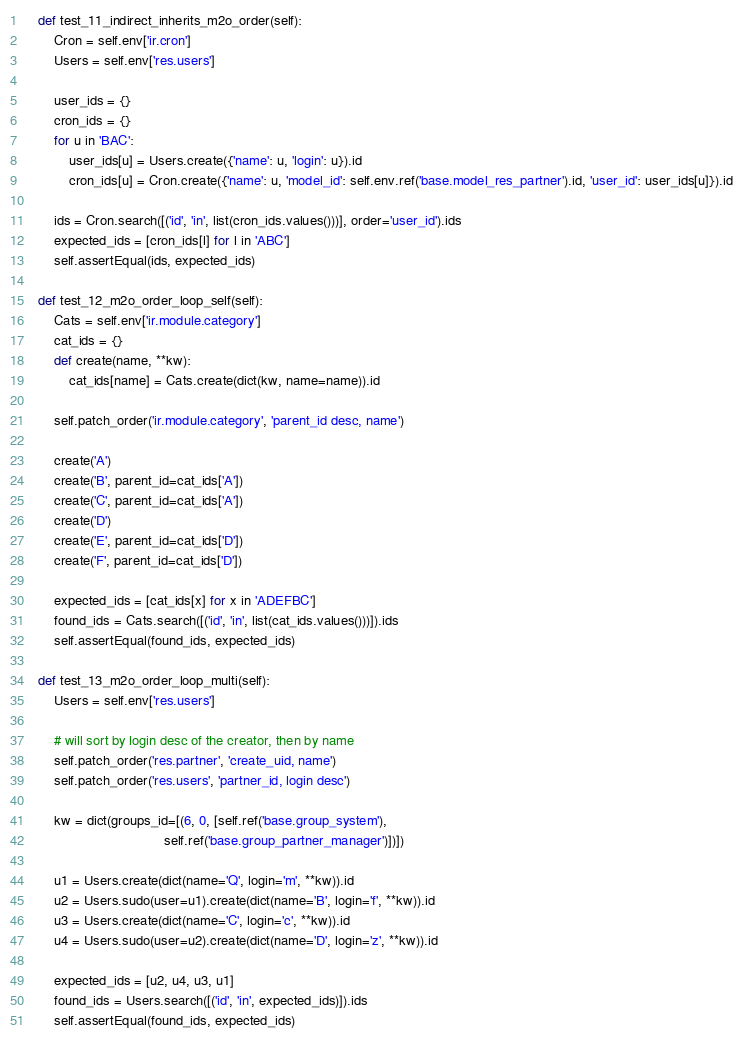<code> <loc_0><loc_0><loc_500><loc_500><_Python_>    def test_11_indirect_inherits_m2o_order(self):
        Cron = self.env['ir.cron']
        Users = self.env['res.users']

        user_ids = {}
        cron_ids = {}
        for u in 'BAC':
            user_ids[u] = Users.create({'name': u, 'login': u}).id
            cron_ids[u] = Cron.create({'name': u, 'model_id': self.env.ref('base.model_res_partner').id, 'user_id': user_ids[u]}).id

        ids = Cron.search([('id', 'in', list(cron_ids.values()))], order='user_id').ids
        expected_ids = [cron_ids[l] for l in 'ABC']
        self.assertEqual(ids, expected_ids)

    def test_12_m2o_order_loop_self(self):
        Cats = self.env['ir.module.category']
        cat_ids = {}
        def create(name, **kw):
            cat_ids[name] = Cats.create(dict(kw, name=name)).id

        self.patch_order('ir.module.category', 'parent_id desc, name')

        create('A')
        create('B', parent_id=cat_ids['A'])
        create('C', parent_id=cat_ids['A'])
        create('D')
        create('E', parent_id=cat_ids['D'])
        create('F', parent_id=cat_ids['D'])

        expected_ids = [cat_ids[x] for x in 'ADEFBC']
        found_ids = Cats.search([('id', 'in', list(cat_ids.values()))]).ids
        self.assertEqual(found_ids, expected_ids)

    def test_13_m2o_order_loop_multi(self):
        Users = self.env['res.users']

        # will sort by login desc of the creator, then by name
        self.patch_order('res.partner', 'create_uid, name')
        self.patch_order('res.users', 'partner_id, login desc')

        kw = dict(groups_id=[(6, 0, [self.ref('base.group_system'),
                                     self.ref('base.group_partner_manager')])])

        u1 = Users.create(dict(name='Q', login='m', **kw)).id
        u2 = Users.sudo(user=u1).create(dict(name='B', login='f', **kw)).id
        u3 = Users.create(dict(name='C', login='c', **kw)).id
        u4 = Users.sudo(user=u2).create(dict(name='D', login='z', **kw)).id

        expected_ids = [u2, u4, u3, u1]
        found_ids = Users.search([('id', 'in', expected_ids)]).ids
        self.assertEqual(found_ids, expected_ids)
</code> 